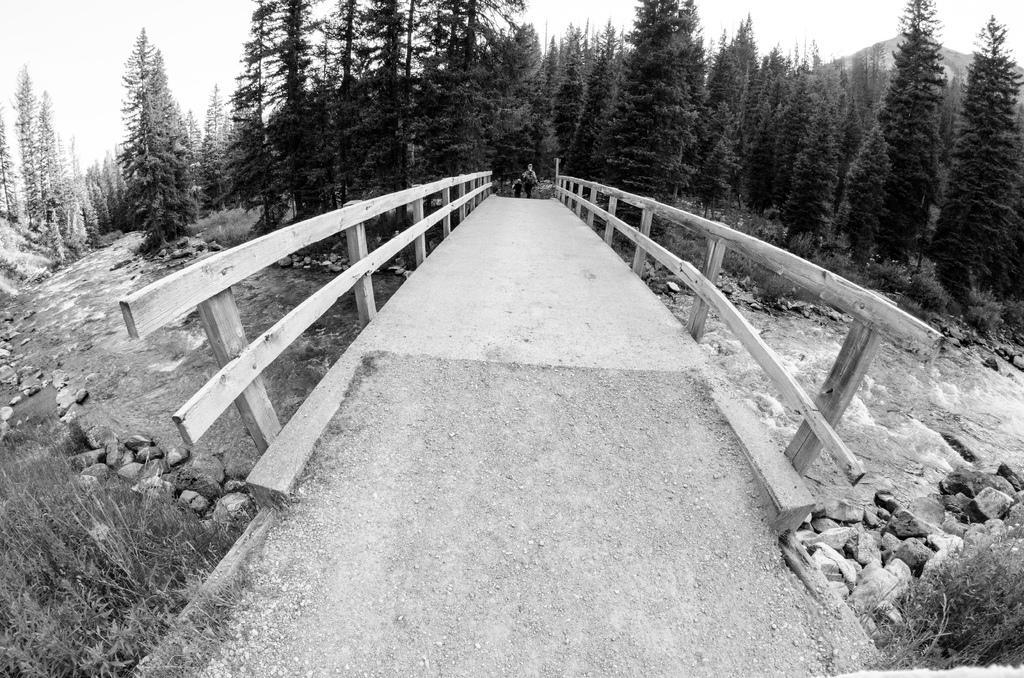Can you describe this image briefly? In the picture I can see the water lake, bridge, some rocks, trees and two people are walking. 